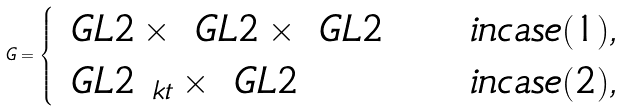Convert formula to latex. <formula><loc_0><loc_0><loc_500><loc_500>G = \begin{cases} \ G L { 2 } \times \ G L { 2 } \times \ G L { 2 } & \quad i n c a s e ( 1 ) , \\ \ G L { 2 } _ { \ k t } \times \ G L { 2 } & \quad i n c a s e ( 2 ) , \end{cases}</formula> 